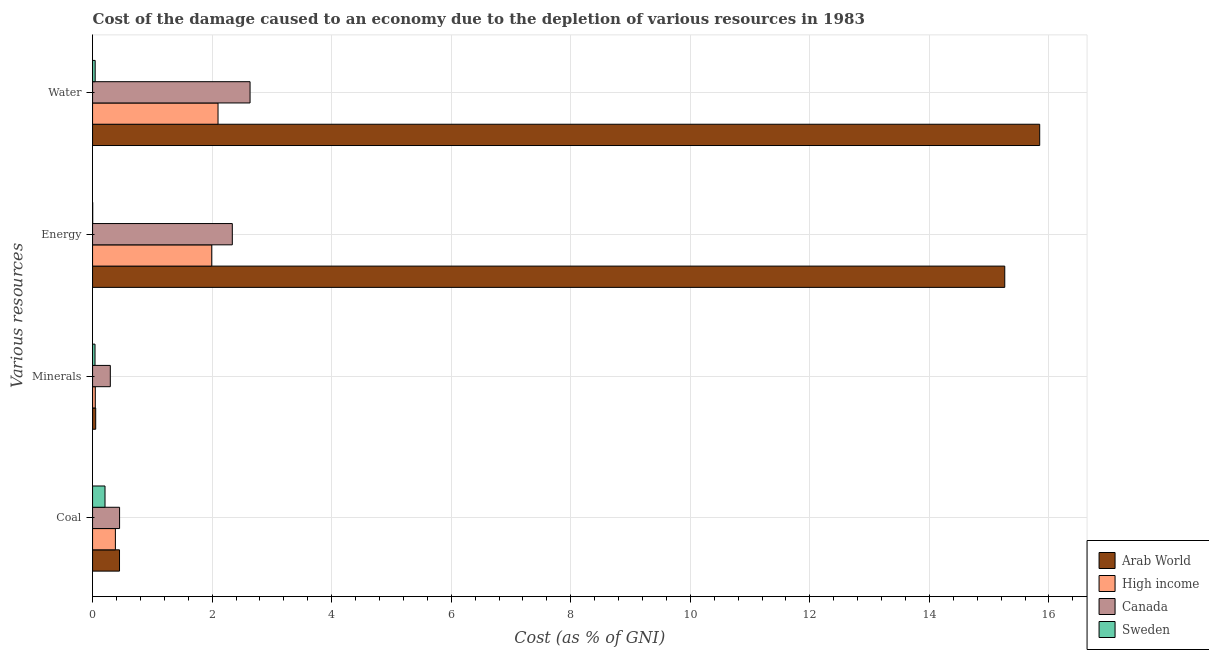How many different coloured bars are there?
Offer a very short reply. 4. Are the number of bars per tick equal to the number of legend labels?
Offer a terse response. Yes. How many bars are there on the 2nd tick from the bottom?
Your response must be concise. 4. What is the label of the 3rd group of bars from the top?
Your response must be concise. Minerals. What is the cost of damage due to depletion of water in High income?
Provide a succinct answer. 2.1. Across all countries, what is the maximum cost of damage due to depletion of energy?
Give a very brief answer. 15.26. Across all countries, what is the minimum cost of damage due to depletion of minerals?
Provide a short and direct response. 0.04. In which country was the cost of damage due to depletion of water maximum?
Provide a succinct answer. Arab World. What is the total cost of damage due to depletion of energy in the graph?
Provide a short and direct response. 19.59. What is the difference between the cost of damage due to depletion of water in High income and that in Sweden?
Give a very brief answer. 2.06. What is the difference between the cost of damage due to depletion of water in Canada and the cost of damage due to depletion of minerals in High income?
Your answer should be compact. 2.59. What is the average cost of damage due to depletion of coal per country?
Your response must be concise. 0.37. What is the difference between the cost of damage due to depletion of minerals and cost of damage due to depletion of water in High income?
Ensure brevity in your answer.  -2.05. In how many countries, is the cost of damage due to depletion of coal greater than 13.6 %?
Your response must be concise. 0. What is the ratio of the cost of damage due to depletion of coal in Arab World to that in High income?
Provide a short and direct response. 1.18. Is the cost of damage due to depletion of minerals in Sweden less than that in Arab World?
Keep it short and to the point. Yes. What is the difference between the highest and the second highest cost of damage due to depletion of energy?
Ensure brevity in your answer.  12.92. What is the difference between the highest and the lowest cost of damage due to depletion of energy?
Your answer should be compact. 15.26. In how many countries, is the cost of damage due to depletion of water greater than the average cost of damage due to depletion of water taken over all countries?
Provide a succinct answer. 1. What does the 3rd bar from the top in Minerals represents?
Ensure brevity in your answer.  High income. Is it the case that in every country, the sum of the cost of damage due to depletion of coal and cost of damage due to depletion of minerals is greater than the cost of damage due to depletion of energy?
Offer a very short reply. No. Are all the bars in the graph horizontal?
Offer a terse response. Yes. How many countries are there in the graph?
Provide a short and direct response. 4. Does the graph contain any zero values?
Provide a short and direct response. No. Does the graph contain grids?
Make the answer very short. Yes. Where does the legend appear in the graph?
Your answer should be very brief. Bottom right. How are the legend labels stacked?
Your answer should be compact. Vertical. What is the title of the graph?
Your answer should be compact. Cost of the damage caused to an economy due to the depletion of various resources in 1983 . What is the label or title of the X-axis?
Offer a very short reply. Cost (as % of GNI). What is the label or title of the Y-axis?
Your answer should be compact. Various resources. What is the Cost (as % of GNI) in Arab World in Coal?
Give a very brief answer. 0.45. What is the Cost (as % of GNI) in High income in Coal?
Make the answer very short. 0.38. What is the Cost (as % of GNI) in Canada in Coal?
Make the answer very short. 0.45. What is the Cost (as % of GNI) in Sweden in Coal?
Your answer should be compact. 0.21. What is the Cost (as % of GNI) in Arab World in Minerals?
Your answer should be very brief. 0.05. What is the Cost (as % of GNI) in High income in Minerals?
Your response must be concise. 0.05. What is the Cost (as % of GNI) of Canada in Minerals?
Make the answer very short. 0.3. What is the Cost (as % of GNI) in Sweden in Minerals?
Ensure brevity in your answer.  0.04. What is the Cost (as % of GNI) in Arab World in Energy?
Keep it short and to the point. 15.26. What is the Cost (as % of GNI) in High income in Energy?
Provide a short and direct response. 1.99. What is the Cost (as % of GNI) in Canada in Energy?
Keep it short and to the point. 2.34. What is the Cost (as % of GNI) in Sweden in Energy?
Give a very brief answer. 0. What is the Cost (as % of GNI) in Arab World in Water?
Provide a short and direct response. 15.84. What is the Cost (as % of GNI) in High income in Water?
Offer a terse response. 2.1. What is the Cost (as % of GNI) of Canada in Water?
Give a very brief answer. 2.63. What is the Cost (as % of GNI) in Sweden in Water?
Offer a terse response. 0.04. Across all Various resources, what is the maximum Cost (as % of GNI) in Arab World?
Your answer should be very brief. 15.84. Across all Various resources, what is the maximum Cost (as % of GNI) in High income?
Provide a succinct answer. 2.1. Across all Various resources, what is the maximum Cost (as % of GNI) in Canada?
Ensure brevity in your answer.  2.63. Across all Various resources, what is the maximum Cost (as % of GNI) of Sweden?
Keep it short and to the point. 0.21. Across all Various resources, what is the minimum Cost (as % of GNI) in Arab World?
Give a very brief answer. 0.05. Across all Various resources, what is the minimum Cost (as % of GNI) of High income?
Ensure brevity in your answer.  0.05. Across all Various resources, what is the minimum Cost (as % of GNI) in Canada?
Your response must be concise. 0.3. Across all Various resources, what is the minimum Cost (as % of GNI) in Sweden?
Provide a succinct answer. 0. What is the total Cost (as % of GNI) in Arab World in the graph?
Offer a very short reply. 31.61. What is the total Cost (as % of GNI) in High income in the graph?
Your answer should be compact. 4.52. What is the total Cost (as % of GNI) in Canada in the graph?
Provide a succinct answer. 5.72. What is the total Cost (as % of GNI) of Sweden in the graph?
Your response must be concise. 0.3. What is the difference between the Cost (as % of GNI) of Arab World in Coal and that in Minerals?
Keep it short and to the point. 0.4. What is the difference between the Cost (as % of GNI) of High income in Coal and that in Minerals?
Offer a terse response. 0.34. What is the difference between the Cost (as % of GNI) in Canada in Coal and that in Minerals?
Keep it short and to the point. 0.16. What is the difference between the Cost (as % of GNI) of Sweden in Coal and that in Minerals?
Provide a short and direct response. 0.17. What is the difference between the Cost (as % of GNI) in Arab World in Coal and that in Energy?
Your answer should be compact. -14.81. What is the difference between the Cost (as % of GNI) of High income in Coal and that in Energy?
Make the answer very short. -1.61. What is the difference between the Cost (as % of GNI) in Canada in Coal and that in Energy?
Offer a terse response. -1.89. What is the difference between the Cost (as % of GNI) in Sweden in Coal and that in Energy?
Give a very brief answer. 0.21. What is the difference between the Cost (as % of GNI) of Arab World in Coal and that in Water?
Offer a very short reply. -15.39. What is the difference between the Cost (as % of GNI) of High income in Coal and that in Water?
Your response must be concise. -1.72. What is the difference between the Cost (as % of GNI) in Canada in Coal and that in Water?
Offer a very short reply. -2.18. What is the difference between the Cost (as % of GNI) of Sweden in Coal and that in Water?
Give a very brief answer. 0.16. What is the difference between the Cost (as % of GNI) of Arab World in Minerals and that in Energy?
Offer a very short reply. -15.21. What is the difference between the Cost (as % of GNI) of High income in Minerals and that in Energy?
Your answer should be very brief. -1.95. What is the difference between the Cost (as % of GNI) in Canada in Minerals and that in Energy?
Provide a succinct answer. -2.04. What is the difference between the Cost (as % of GNI) of Sweden in Minerals and that in Energy?
Your response must be concise. 0.04. What is the difference between the Cost (as % of GNI) in Arab World in Minerals and that in Water?
Provide a short and direct response. -15.79. What is the difference between the Cost (as % of GNI) in High income in Minerals and that in Water?
Offer a very short reply. -2.05. What is the difference between the Cost (as % of GNI) of Canada in Minerals and that in Water?
Your answer should be compact. -2.34. What is the difference between the Cost (as % of GNI) in Sweden in Minerals and that in Water?
Offer a terse response. -0. What is the difference between the Cost (as % of GNI) of Arab World in Energy and that in Water?
Provide a succinct answer. -0.58. What is the difference between the Cost (as % of GNI) of High income in Energy and that in Water?
Your answer should be compact. -0.11. What is the difference between the Cost (as % of GNI) of Canada in Energy and that in Water?
Your answer should be very brief. -0.3. What is the difference between the Cost (as % of GNI) of Sweden in Energy and that in Water?
Offer a terse response. -0.04. What is the difference between the Cost (as % of GNI) in Arab World in Coal and the Cost (as % of GNI) in High income in Minerals?
Offer a very short reply. 0.41. What is the difference between the Cost (as % of GNI) of Arab World in Coal and the Cost (as % of GNI) of Canada in Minerals?
Provide a succinct answer. 0.15. What is the difference between the Cost (as % of GNI) in Arab World in Coal and the Cost (as % of GNI) in Sweden in Minerals?
Provide a short and direct response. 0.41. What is the difference between the Cost (as % of GNI) of High income in Coal and the Cost (as % of GNI) of Canada in Minerals?
Provide a short and direct response. 0.08. What is the difference between the Cost (as % of GNI) of High income in Coal and the Cost (as % of GNI) of Sweden in Minerals?
Offer a terse response. 0.34. What is the difference between the Cost (as % of GNI) of Canada in Coal and the Cost (as % of GNI) of Sweden in Minerals?
Offer a very short reply. 0.41. What is the difference between the Cost (as % of GNI) of Arab World in Coal and the Cost (as % of GNI) of High income in Energy?
Make the answer very short. -1.54. What is the difference between the Cost (as % of GNI) in Arab World in Coal and the Cost (as % of GNI) in Canada in Energy?
Give a very brief answer. -1.89. What is the difference between the Cost (as % of GNI) of Arab World in Coal and the Cost (as % of GNI) of Sweden in Energy?
Give a very brief answer. 0.45. What is the difference between the Cost (as % of GNI) of High income in Coal and the Cost (as % of GNI) of Canada in Energy?
Your answer should be compact. -1.96. What is the difference between the Cost (as % of GNI) in High income in Coal and the Cost (as % of GNI) in Sweden in Energy?
Provide a succinct answer. 0.38. What is the difference between the Cost (as % of GNI) in Canada in Coal and the Cost (as % of GNI) in Sweden in Energy?
Provide a succinct answer. 0.45. What is the difference between the Cost (as % of GNI) of Arab World in Coal and the Cost (as % of GNI) of High income in Water?
Your answer should be compact. -1.65. What is the difference between the Cost (as % of GNI) in Arab World in Coal and the Cost (as % of GNI) in Canada in Water?
Provide a short and direct response. -2.18. What is the difference between the Cost (as % of GNI) of Arab World in Coal and the Cost (as % of GNI) of Sweden in Water?
Ensure brevity in your answer.  0.41. What is the difference between the Cost (as % of GNI) in High income in Coal and the Cost (as % of GNI) in Canada in Water?
Give a very brief answer. -2.25. What is the difference between the Cost (as % of GNI) in High income in Coal and the Cost (as % of GNI) in Sweden in Water?
Give a very brief answer. 0.34. What is the difference between the Cost (as % of GNI) of Canada in Coal and the Cost (as % of GNI) of Sweden in Water?
Provide a short and direct response. 0.41. What is the difference between the Cost (as % of GNI) of Arab World in Minerals and the Cost (as % of GNI) of High income in Energy?
Your answer should be very brief. -1.94. What is the difference between the Cost (as % of GNI) in Arab World in Minerals and the Cost (as % of GNI) in Canada in Energy?
Provide a succinct answer. -2.29. What is the difference between the Cost (as % of GNI) of High income in Minerals and the Cost (as % of GNI) of Canada in Energy?
Make the answer very short. -2.29. What is the difference between the Cost (as % of GNI) of High income in Minerals and the Cost (as % of GNI) of Sweden in Energy?
Provide a succinct answer. 0.04. What is the difference between the Cost (as % of GNI) in Canada in Minerals and the Cost (as % of GNI) in Sweden in Energy?
Make the answer very short. 0.29. What is the difference between the Cost (as % of GNI) of Arab World in Minerals and the Cost (as % of GNI) of High income in Water?
Keep it short and to the point. -2.05. What is the difference between the Cost (as % of GNI) in Arab World in Minerals and the Cost (as % of GNI) in Canada in Water?
Your answer should be very brief. -2.58. What is the difference between the Cost (as % of GNI) of Arab World in Minerals and the Cost (as % of GNI) of Sweden in Water?
Your answer should be compact. 0.01. What is the difference between the Cost (as % of GNI) in High income in Minerals and the Cost (as % of GNI) in Canada in Water?
Your answer should be very brief. -2.59. What is the difference between the Cost (as % of GNI) of High income in Minerals and the Cost (as % of GNI) of Sweden in Water?
Offer a very short reply. 0. What is the difference between the Cost (as % of GNI) in Canada in Minerals and the Cost (as % of GNI) in Sweden in Water?
Offer a very short reply. 0.25. What is the difference between the Cost (as % of GNI) in Arab World in Energy and the Cost (as % of GNI) in High income in Water?
Offer a terse response. 13.16. What is the difference between the Cost (as % of GNI) in Arab World in Energy and the Cost (as % of GNI) in Canada in Water?
Make the answer very short. 12.63. What is the difference between the Cost (as % of GNI) of Arab World in Energy and the Cost (as % of GNI) of Sweden in Water?
Provide a succinct answer. 15.22. What is the difference between the Cost (as % of GNI) of High income in Energy and the Cost (as % of GNI) of Canada in Water?
Give a very brief answer. -0.64. What is the difference between the Cost (as % of GNI) in High income in Energy and the Cost (as % of GNI) in Sweden in Water?
Provide a succinct answer. 1.95. What is the difference between the Cost (as % of GNI) of Canada in Energy and the Cost (as % of GNI) of Sweden in Water?
Give a very brief answer. 2.29. What is the average Cost (as % of GNI) of Arab World per Various resources?
Offer a very short reply. 7.9. What is the average Cost (as % of GNI) in High income per Various resources?
Provide a short and direct response. 1.13. What is the average Cost (as % of GNI) in Canada per Various resources?
Your answer should be very brief. 1.43. What is the average Cost (as % of GNI) in Sweden per Various resources?
Provide a succinct answer. 0.07. What is the difference between the Cost (as % of GNI) of Arab World and Cost (as % of GNI) of High income in Coal?
Your response must be concise. 0.07. What is the difference between the Cost (as % of GNI) of Arab World and Cost (as % of GNI) of Canada in Coal?
Your answer should be compact. -0. What is the difference between the Cost (as % of GNI) in Arab World and Cost (as % of GNI) in Sweden in Coal?
Keep it short and to the point. 0.24. What is the difference between the Cost (as % of GNI) of High income and Cost (as % of GNI) of Canada in Coal?
Offer a very short reply. -0.07. What is the difference between the Cost (as % of GNI) of High income and Cost (as % of GNI) of Sweden in Coal?
Make the answer very short. 0.17. What is the difference between the Cost (as % of GNI) of Canada and Cost (as % of GNI) of Sweden in Coal?
Make the answer very short. 0.24. What is the difference between the Cost (as % of GNI) of Arab World and Cost (as % of GNI) of High income in Minerals?
Offer a terse response. 0.01. What is the difference between the Cost (as % of GNI) in Arab World and Cost (as % of GNI) in Canada in Minerals?
Your answer should be compact. -0.24. What is the difference between the Cost (as % of GNI) of Arab World and Cost (as % of GNI) of Sweden in Minerals?
Offer a very short reply. 0.01. What is the difference between the Cost (as % of GNI) in High income and Cost (as % of GNI) in Canada in Minerals?
Give a very brief answer. -0.25. What is the difference between the Cost (as % of GNI) in High income and Cost (as % of GNI) in Sweden in Minerals?
Your response must be concise. 0. What is the difference between the Cost (as % of GNI) of Canada and Cost (as % of GNI) of Sweden in Minerals?
Ensure brevity in your answer.  0.26. What is the difference between the Cost (as % of GNI) of Arab World and Cost (as % of GNI) of High income in Energy?
Your answer should be very brief. 13.27. What is the difference between the Cost (as % of GNI) in Arab World and Cost (as % of GNI) in Canada in Energy?
Make the answer very short. 12.92. What is the difference between the Cost (as % of GNI) of Arab World and Cost (as % of GNI) of Sweden in Energy?
Provide a short and direct response. 15.26. What is the difference between the Cost (as % of GNI) of High income and Cost (as % of GNI) of Canada in Energy?
Give a very brief answer. -0.34. What is the difference between the Cost (as % of GNI) in High income and Cost (as % of GNI) in Sweden in Energy?
Your answer should be very brief. 1.99. What is the difference between the Cost (as % of GNI) in Canada and Cost (as % of GNI) in Sweden in Energy?
Offer a terse response. 2.34. What is the difference between the Cost (as % of GNI) in Arab World and Cost (as % of GNI) in High income in Water?
Your response must be concise. 13.75. What is the difference between the Cost (as % of GNI) in Arab World and Cost (as % of GNI) in Canada in Water?
Offer a terse response. 13.21. What is the difference between the Cost (as % of GNI) in Arab World and Cost (as % of GNI) in Sweden in Water?
Your response must be concise. 15.8. What is the difference between the Cost (as % of GNI) in High income and Cost (as % of GNI) in Canada in Water?
Your response must be concise. -0.54. What is the difference between the Cost (as % of GNI) of High income and Cost (as % of GNI) of Sweden in Water?
Keep it short and to the point. 2.06. What is the difference between the Cost (as % of GNI) in Canada and Cost (as % of GNI) in Sweden in Water?
Give a very brief answer. 2.59. What is the ratio of the Cost (as % of GNI) in Arab World in Coal to that in Minerals?
Your response must be concise. 8.58. What is the ratio of the Cost (as % of GNI) of High income in Coal to that in Minerals?
Offer a very short reply. 8.34. What is the ratio of the Cost (as % of GNI) in Canada in Coal to that in Minerals?
Your response must be concise. 1.52. What is the ratio of the Cost (as % of GNI) in Sweden in Coal to that in Minerals?
Your answer should be compact. 5.07. What is the ratio of the Cost (as % of GNI) in Arab World in Coal to that in Energy?
Offer a terse response. 0.03. What is the ratio of the Cost (as % of GNI) in High income in Coal to that in Energy?
Your answer should be very brief. 0.19. What is the ratio of the Cost (as % of GNI) of Canada in Coal to that in Energy?
Keep it short and to the point. 0.19. What is the ratio of the Cost (as % of GNI) in Sweden in Coal to that in Energy?
Give a very brief answer. 80.36. What is the ratio of the Cost (as % of GNI) in Arab World in Coal to that in Water?
Make the answer very short. 0.03. What is the ratio of the Cost (as % of GNI) of High income in Coal to that in Water?
Give a very brief answer. 0.18. What is the ratio of the Cost (as % of GNI) in Canada in Coal to that in Water?
Your answer should be compact. 0.17. What is the ratio of the Cost (as % of GNI) of Sweden in Coal to that in Water?
Your answer should be very brief. 4.77. What is the ratio of the Cost (as % of GNI) of Arab World in Minerals to that in Energy?
Make the answer very short. 0. What is the ratio of the Cost (as % of GNI) of High income in Minerals to that in Energy?
Keep it short and to the point. 0.02. What is the ratio of the Cost (as % of GNI) of Canada in Minerals to that in Energy?
Your response must be concise. 0.13. What is the ratio of the Cost (as % of GNI) of Sweden in Minerals to that in Energy?
Provide a succinct answer. 15.85. What is the ratio of the Cost (as % of GNI) of Arab World in Minerals to that in Water?
Offer a very short reply. 0. What is the ratio of the Cost (as % of GNI) of High income in Minerals to that in Water?
Offer a very short reply. 0.02. What is the ratio of the Cost (as % of GNI) in Canada in Minerals to that in Water?
Offer a very short reply. 0.11. What is the ratio of the Cost (as % of GNI) of Sweden in Minerals to that in Water?
Ensure brevity in your answer.  0.94. What is the ratio of the Cost (as % of GNI) in Arab World in Energy to that in Water?
Provide a succinct answer. 0.96. What is the ratio of the Cost (as % of GNI) in High income in Energy to that in Water?
Keep it short and to the point. 0.95. What is the ratio of the Cost (as % of GNI) of Canada in Energy to that in Water?
Provide a short and direct response. 0.89. What is the ratio of the Cost (as % of GNI) in Sweden in Energy to that in Water?
Provide a succinct answer. 0.06. What is the difference between the highest and the second highest Cost (as % of GNI) of Arab World?
Give a very brief answer. 0.58. What is the difference between the highest and the second highest Cost (as % of GNI) of High income?
Ensure brevity in your answer.  0.11. What is the difference between the highest and the second highest Cost (as % of GNI) of Canada?
Your answer should be compact. 0.3. What is the difference between the highest and the second highest Cost (as % of GNI) in Sweden?
Your answer should be very brief. 0.16. What is the difference between the highest and the lowest Cost (as % of GNI) in Arab World?
Keep it short and to the point. 15.79. What is the difference between the highest and the lowest Cost (as % of GNI) of High income?
Offer a very short reply. 2.05. What is the difference between the highest and the lowest Cost (as % of GNI) in Canada?
Ensure brevity in your answer.  2.34. What is the difference between the highest and the lowest Cost (as % of GNI) of Sweden?
Your answer should be compact. 0.21. 